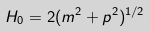Convert formula to latex. <formula><loc_0><loc_0><loc_500><loc_500>H _ { 0 } = 2 ( m ^ { 2 } + { p } ^ { 2 } ) ^ { 1 / 2 }</formula> 